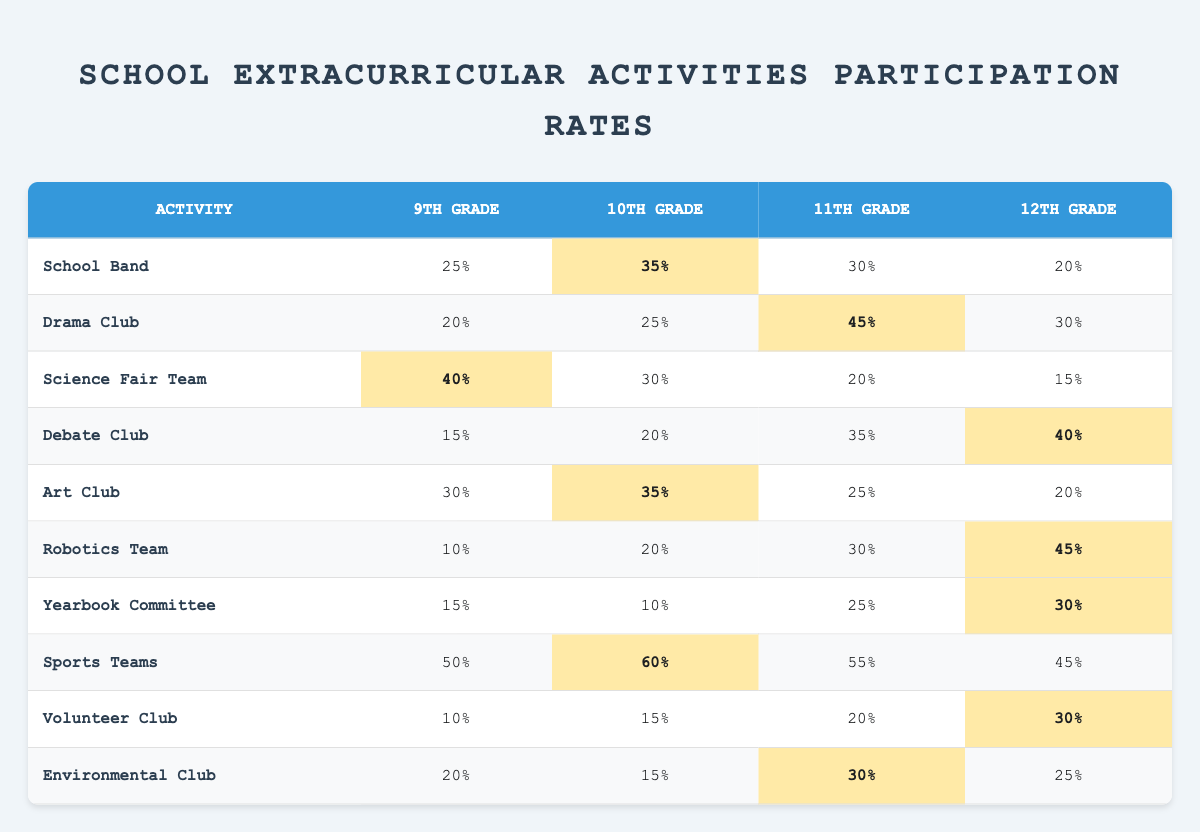What is the participation rate for 12th grade in the Robotics Team? Looking at the Robotics Team row under the 12th Grade column, the value is 45%.
Answer: 45% Which extracurricular activity has the highest participation rate for 10th grade? In the 10th Grade column, the highest value is 60%, which corresponds to the Sports Teams activity.
Answer: Sports Teams What is the difference in participation rates between 11th grade and 12th grade in the Debate Club? The participation rate for 11th grade in the Debate Club is 35% and for 12th grade is 40%. The difference is 40% - 35% = 5%.
Answer: 5% Which activity has the lowest participation rate for 9th grade? In the 9th Grade column, the activity with the lowest value is the Robotics Team with a participation rate of 10%.
Answer: Robotics Team What is the average participation rate for 10th grade across all activities? The 10th Grade participation rates are 35%, 25%, 30%, 20%, 35%, 20%, 10%, 60%, 15%, and 15%. The sum is 25 + 20 + 30 + 20 + 35 + 20 + 10 + 60 + 15 + 15 =  25 + 20 + 30 + 20 + 35 + 20 + 10 + 60 + 15 + 15 = 50 + 35 + 20 + 60 + 15 + 15 = 335. There are 10 values, so the average is 335 / 10 = 33.5%.
Answer: 33.5% Is there a higher participation rate for 12th grade in Sports Teams compared to Environmental Club? The participation rate for Sports Teams in 12th grade is 45%, and for Environmental Club, it is 25%. Since 45% is greater than 25%, the answer is yes.
Answer: Yes Which grade level has the highest participation rate in the Drama Club? In the Drama Club, the highest participation rate is for the 11th grade, which has a value of 45%.
Answer: 11th Grade What is the sum of participation rates for both 9th and 10th grades in the Yearbook Committee? The Yearbook Committee has participation rates of 15% for 9th grade and 10% for 10th grade. The sum is 15% + 10% = 25%.
Answer: 25% What is the participation rate for the Art Club in 11th grade and how does it compare to the rate in 12th grade? The participation rate for the Art Club in 11th grade is 25%, and in 12th grade, it is 20%. Therefore, 25% is greater than 20%.
Answer: 25% (greater than 20%) What extracurricular activity has the same participation rate for 12th grade as the Volunteer Club's participation rate for 11th grade? The Volunteer Club has a participation rate of 20% in 11th grade, and the Environmental Club has a participation rate of 25% in 12th grade, while Robotics Team has 45%. No activity matches this condition.
Answer: None What is the participation rate for the Science Fair Team across all grades, and which grade shows the highest participation? The participation rates are 40% for 9th grade, 30% for 10th grade, 20% for 11th grade, and 15% for 12th grade. The highest participation is in 9th grade at 40%.
Answer: 40% (highest in 9th grade) 